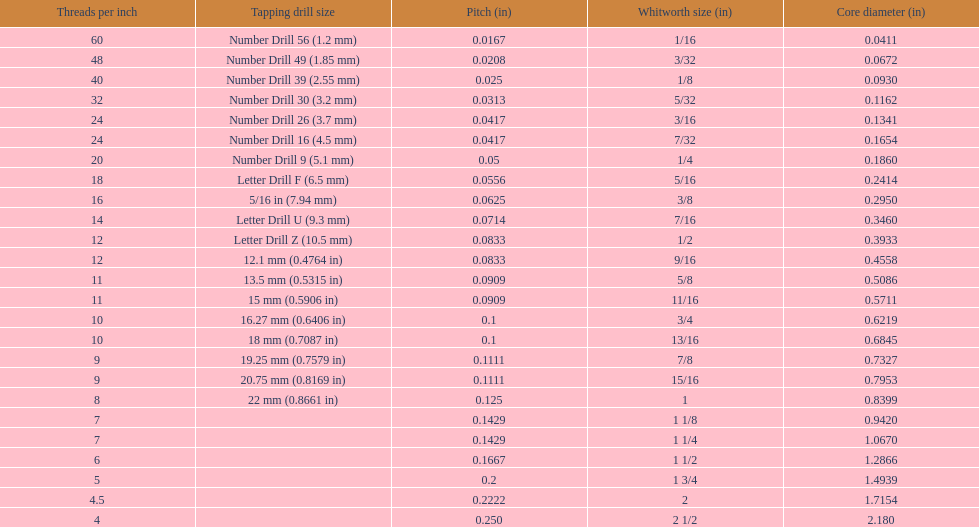Which whitworth size is the only one that has 5 threads per inch? 1 3/4. 